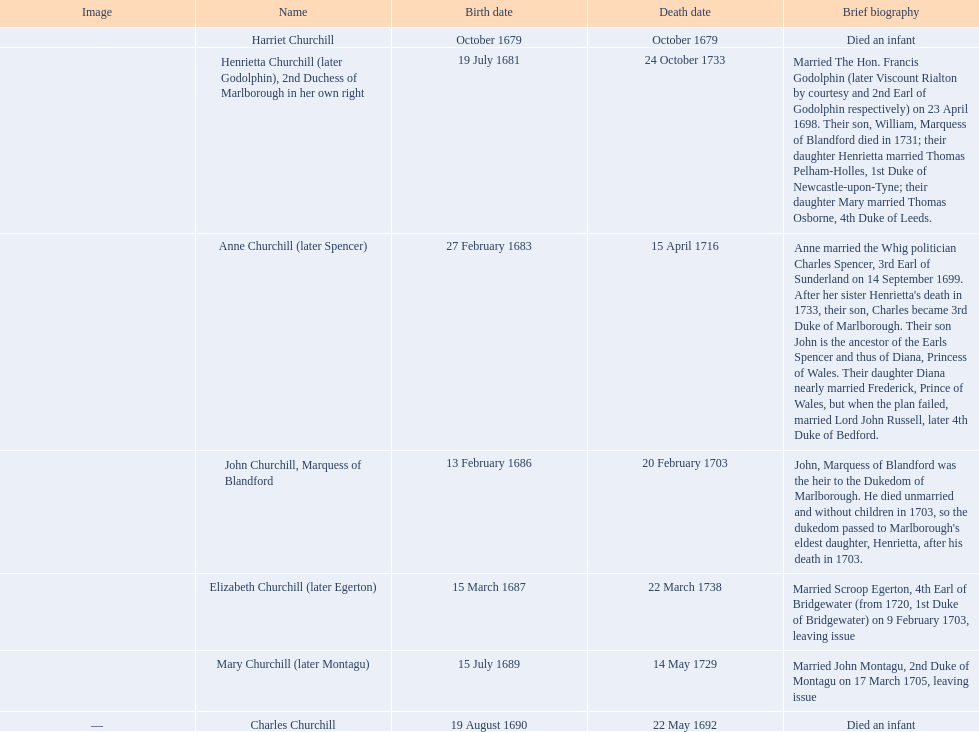Who was the first child to lose their life? Harriet Churchill. 